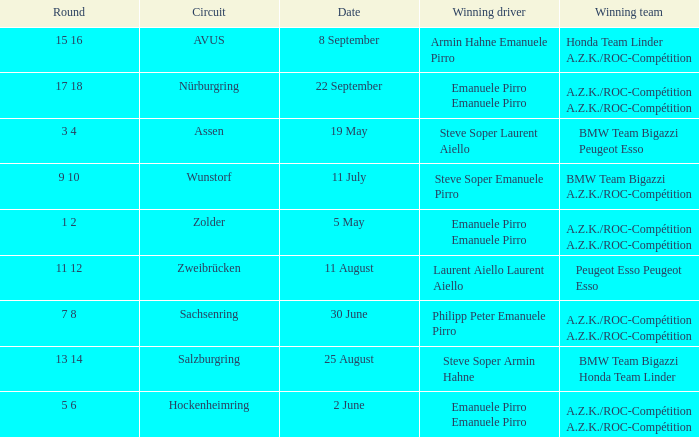Who is the winning driver of the race on 2 June with a.z.k./roc-compétition a.z.k./roc-compétition as the winning team? Emanuele Pirro Emanuele Pirro. 